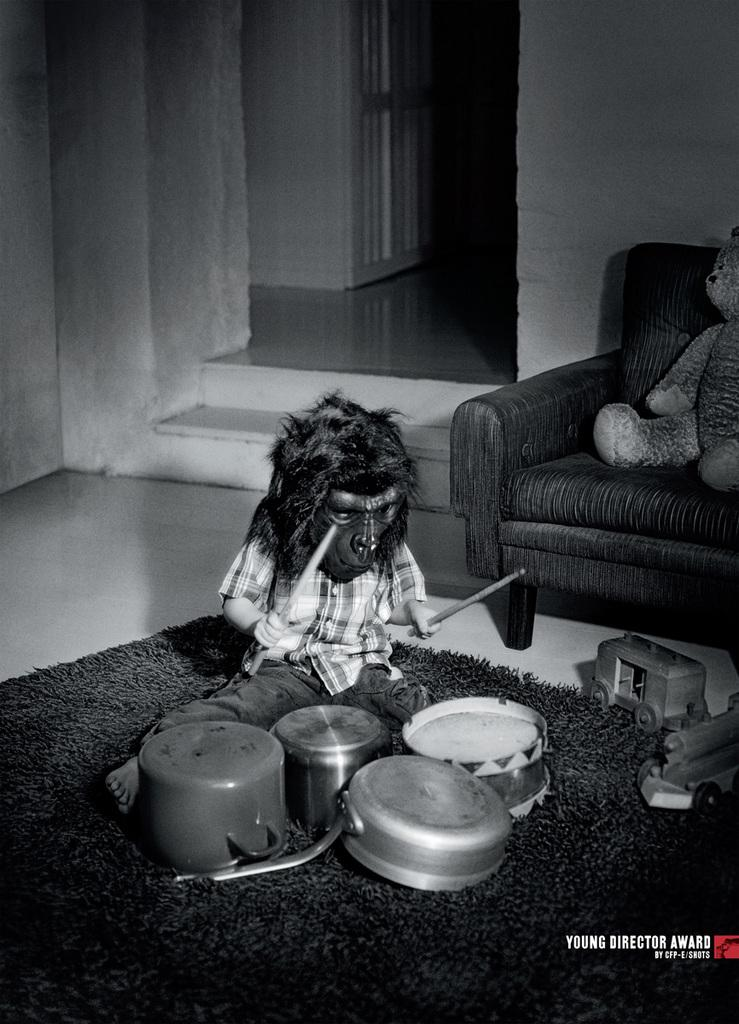What animal is present in the image? There is a monkey in the image. What is the monkey doing in the image? The monkey is playing with kitchen utensils. Where are the kitchen utensils located in the image? The kitchen utensils are placed on the floor. What can be seen in the background of the image? There is a door and a sofa in the background of the image. What is placed on the sofa in the image? A teddy bear is placed on the sofa. How many tickets are needed to ride the lift in the image? There is no lift present in the image, so the number of tickets needed cannot be determined. 